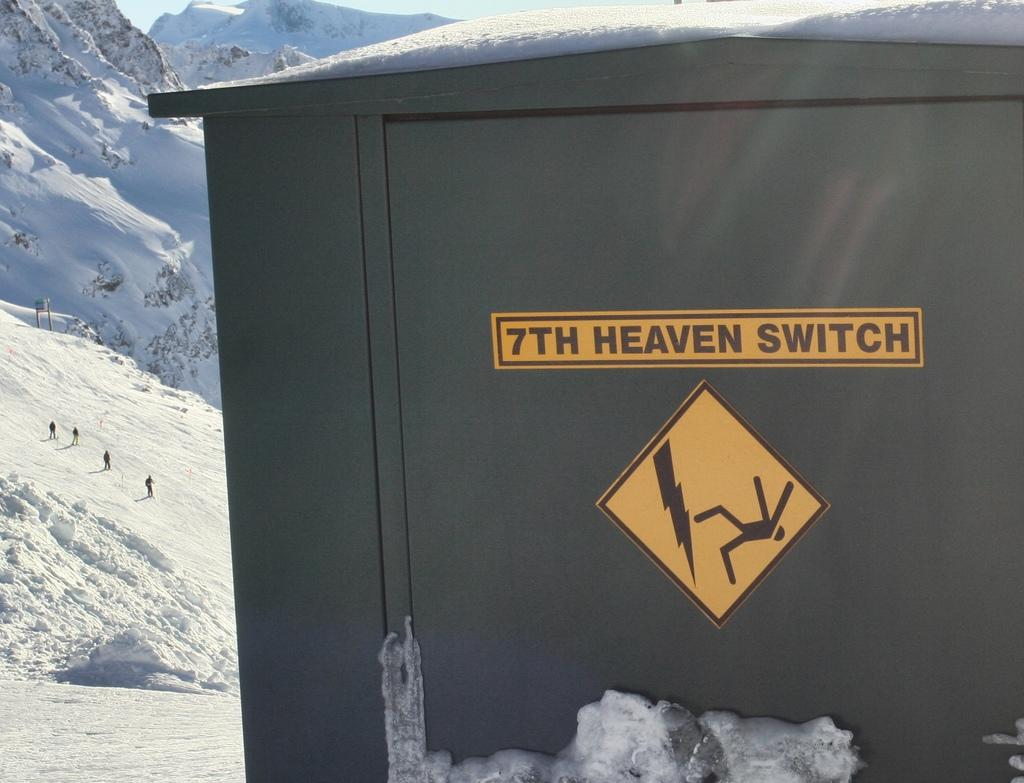Provide a one-sentence caption for the provided image. An electrical box in the snowy mountains with a caution sign on it. 